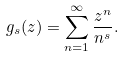<formula> <loc_0><loc_0><loc_500><loc_500>g _ { s } ( z ) = \sum _ { n = 1 } ^ { \infty } \frac { z ^ { n } } { n ^ { s } } . \\</formula> 